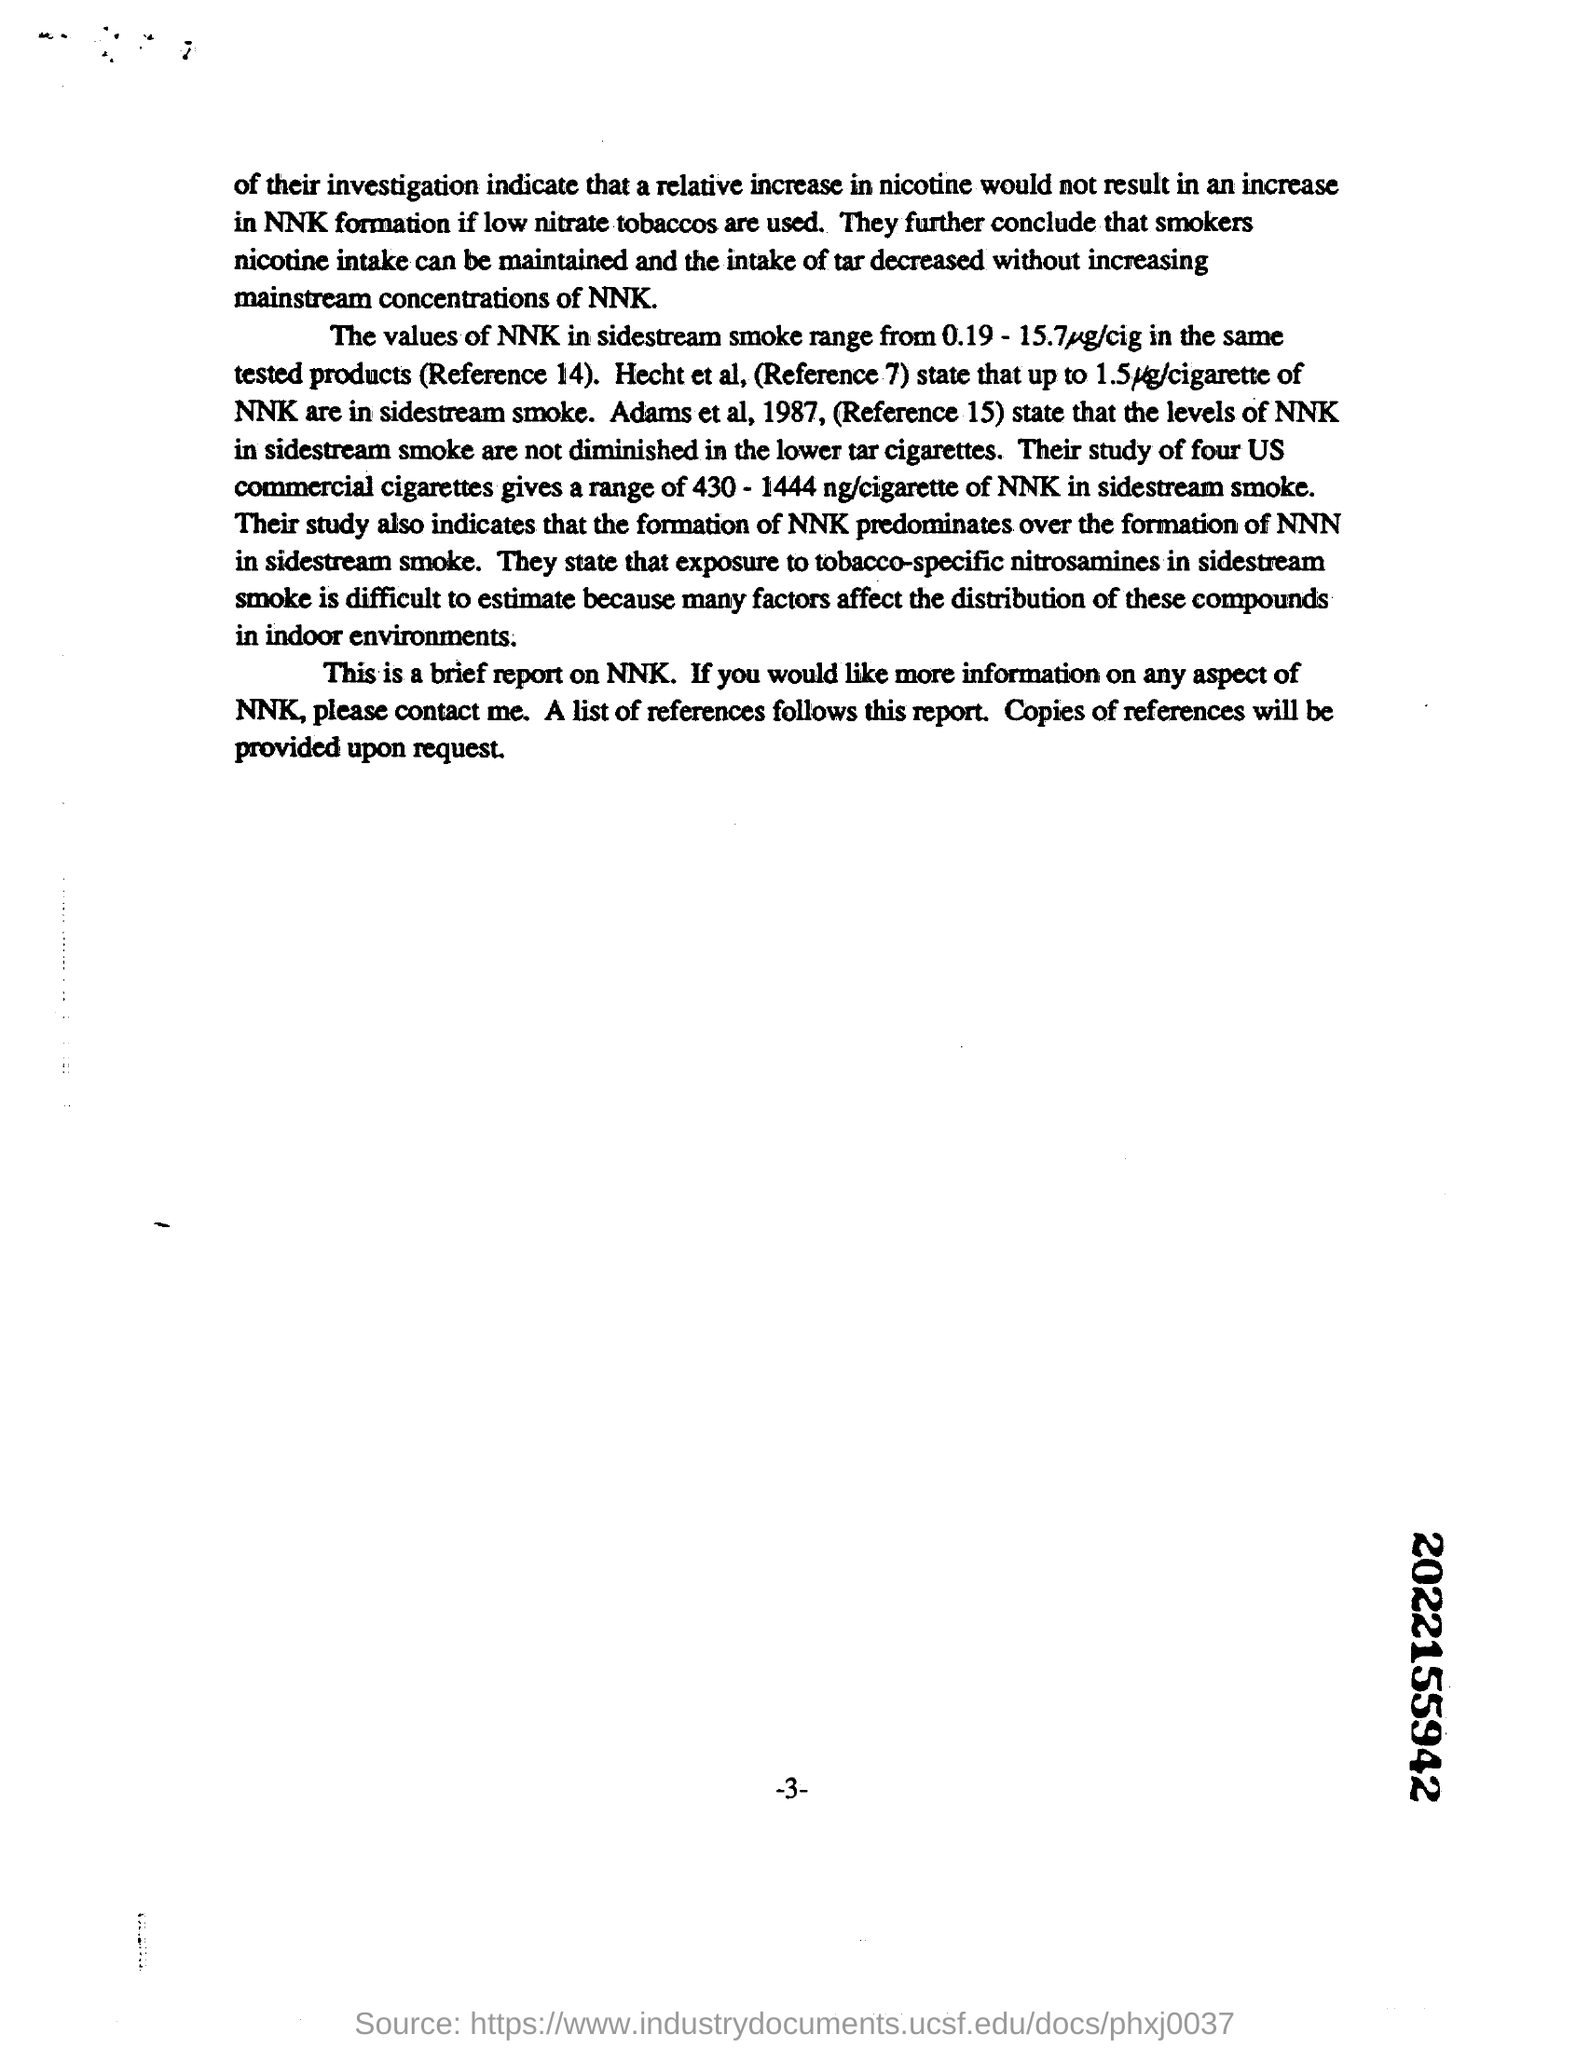Highlight a few significant elements in this photo. It is recommended to use low nitrate tobaccos to reduce the formation of NNk, a harmful compound found in tobacco smoke. 